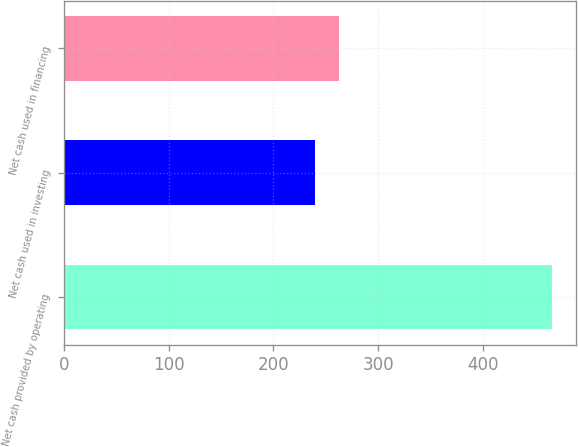Convert chart. <chart><loc_0><loc_0><loc_500><loc_500><bar_chart><fcel>Net cash provided by operating<fcel>Net cash used in investing<fcel>Net cash used in financing<nl><fcel>465.2<fcel>239.7<fcel>262.25<nl></chart> 